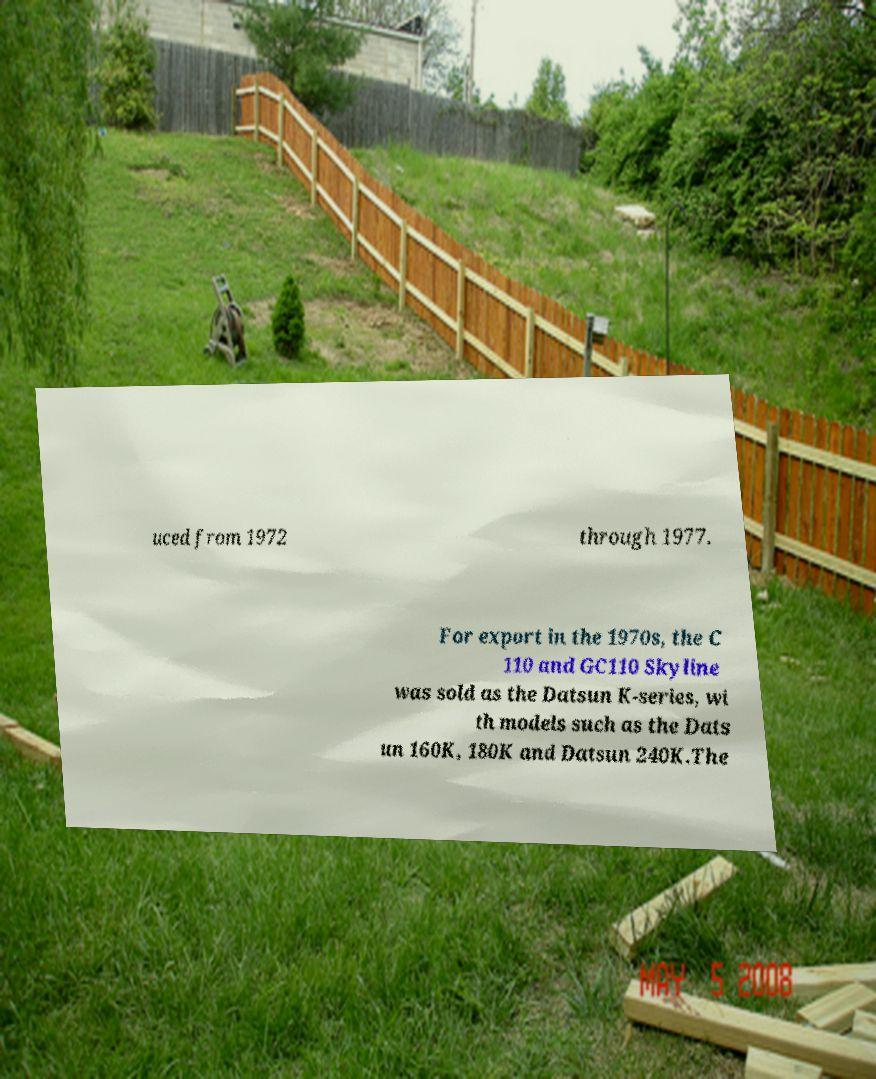Please read and relay the text visible in this image. What does it say? uced from 1972 through 1977. For export in the 1970s, the C 110 and GC110 Skyline was sold as the Datsun K-series, wi th models such as the Dats un 160K, 180K and Datsun 240K.The 